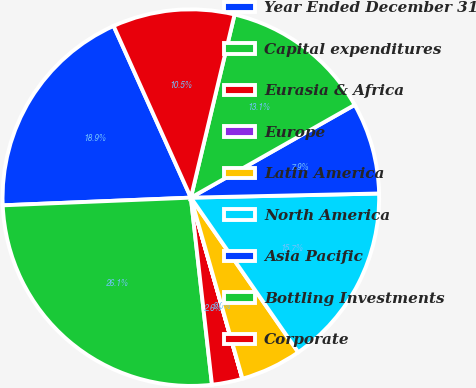Convert chart to OTSL. <chart><loc_0><loc_0><loc_500><loc_500><pie_chart><fcel>Year Ended December 31<fcel>Capital expenditures<fcel>Eurasia & Africa<fcel>Europe<fcel>Latin America<fcel>North America<fcel>Asia Pacific<fcel>Bottling Investments<fcel>Corporate<nl><fcel>18.92%<fcel>26.14%<fcel>2.62%<fcel>0.01%<fcel>5.24%<fcel>15.69%<fcel>7.85%<fcel>13.07%<fcel>10.46%<nl></chart> 